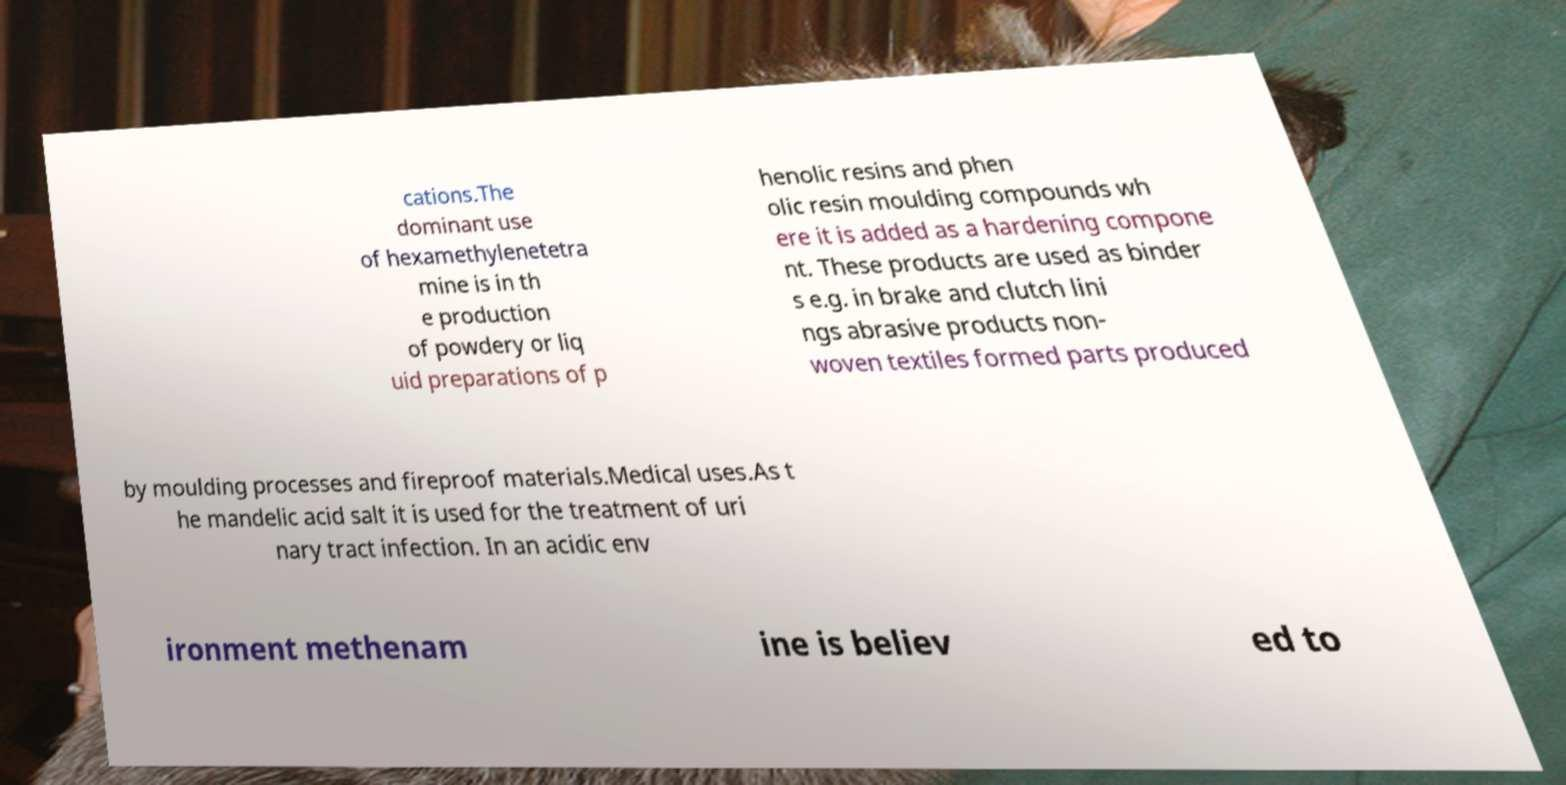Can you accurately transcribe the text from the provided image for me? cations.The dominant use of hexamethylenetetra mine is in th e production of powdery or liq uid preparations of p henolic resins and phen olic resin moulding compounds wh ere it is added as a hardening compone nt. These products are used as binder s e.g. in brake and clutch lini ngs abrasive products non- woven textiles formed parts produced by moulding processes and fireproof materials.Medical uses.As t he mandelic acid salt it is used for the treatment of uri nary tract infection. In an acidic env ironment methenam ine is believ ed to 